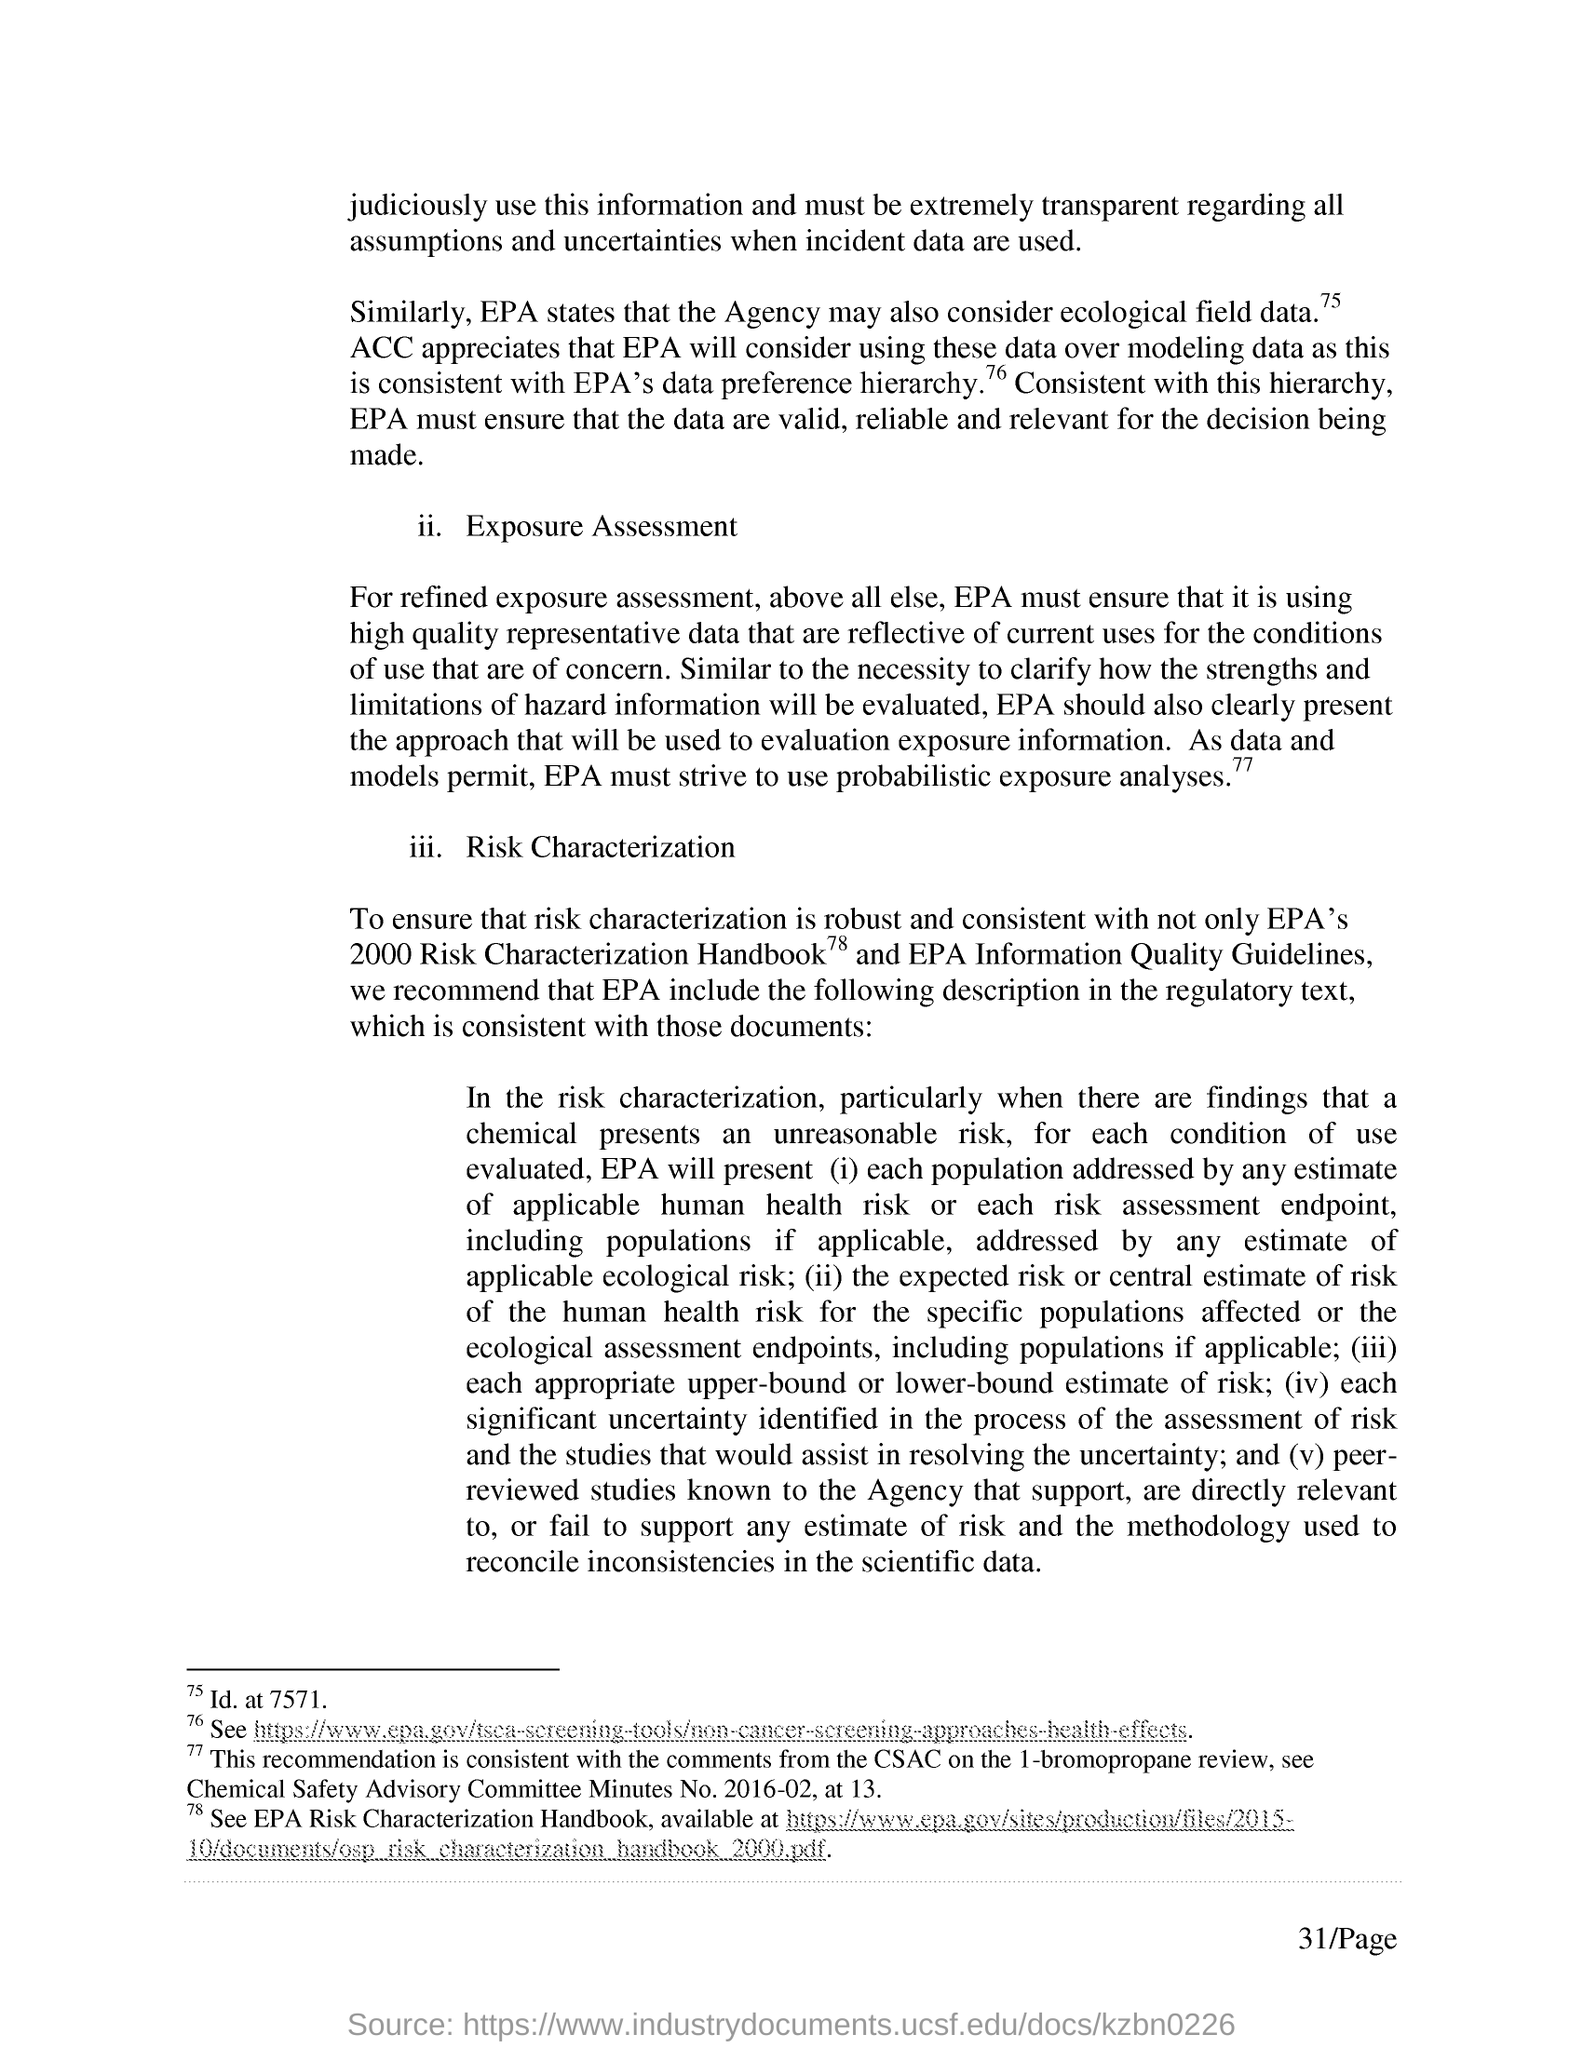List a handful of essential elements in this visual. The Chemical Safety Advisory Committee, abbreviated as CSAC, is a committee established to provide recommendations and advice on chemical safety matters to the relevant authorities. The document mentions page 31. 